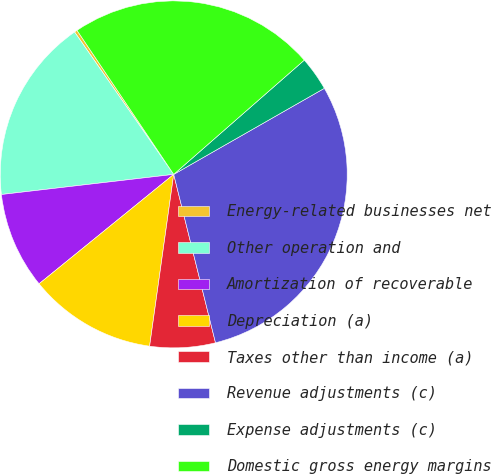<chart> <loc_0><loc_0><loc_500><loc_500><pie_chart><fcel>Energy-related businesses net<fcel>Other operation and<fcel>Amortization of recoverable<fcel>Depreciation (a)<fcel>Taxes other than income (a)<fcel>Revenue adjustments (c)<fcel>Expense adjustments (c)<fcel>Domestic gross energy margins<nl><fcel>0.27%<fcel>17.17%<fcel>9.01%<fcel>11.92%<fcel>6.09%<fcel>29.39%<fcel>3.18%<fcel>22.97%<nl></chart> 